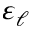<formula> <loc_0><loc_0><loc_500><loc_500>\varepsilon _ { \ell }</formula> 